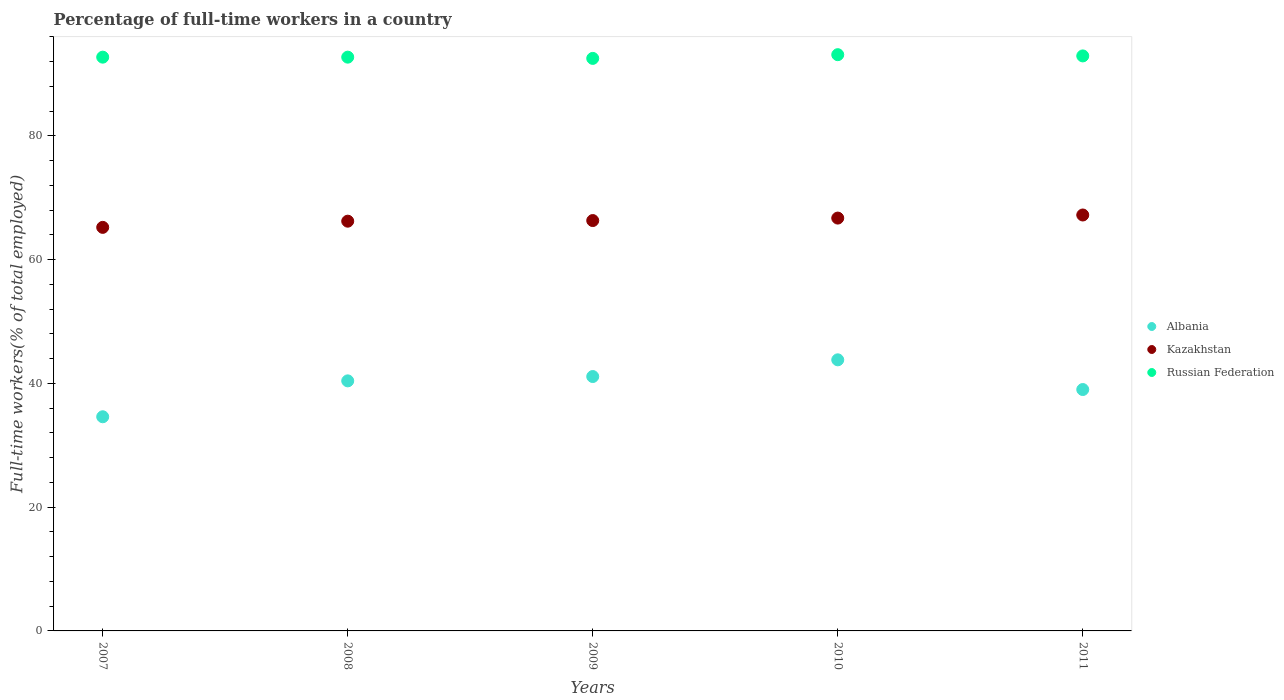How many different coloured dotlines are there?
Your response must be concise. 3. Is the number of dotlines equal to the number of legend labels?
Your answer should be very brief. Yes. What is the percentage of full-time workers in Albania in 2009?
Offer a terse response. 41.1. Across all years, what is the maximum percentage of full-time workers in Albania?
Your answer should be compact. 43.8. Across all years, what is the minimum percentage of full-time workers in Albania?
Provide a short and direct response. 34.6. In which year was the percentage of full-time workers in Russian Federation maximum?
Provide a short and direct response. 2010. What is the total percentage of full-time workers in Russian Federation in the graph?
Your response must be concise. 463.9. What is the difference between the percentage of full-time workers in Russian Federation in 2008 and that in 2009?
Give a very brief answer. 0.2. What is the difference between the percentage of full-time workers in Russian Federation in 2011 and the percentage of full-time workers in Kazakhstan in 2008?
Make the answer very short. 26.7. What is the average percentage of full-time workers in Kazakhstan per year?
Your response must be concise. 66.32. In the year 2011, what is the difference between the percentage of full-time workers in Russian Federation and percentage of full-time workers in Kazakhstan?
Make the answer very short. 25.7. What is the ratio of the percentage of full-time workers in Albania in 2009 to that in 2010?
Keep it short and to the point. 0.94. Is the percentage of full-time workers in Kazakhstan in 2008 less than that in 2011?
Give a very brief answer. Yes. What is the difference between the highest and the lowest percentage of full-time workers in Russian Federation?
Offer a very short reply. 0.6. Does the percentage of full-time workers in Kazakhstan monotonically increase over the years?
Your answer should be compact. Yes. Is the percentage of full-time workers in Kazakhstan strictly less than the percentage of full-time workers in Russian Federation over the years?
Your answer should be compact. Yes. How many dotlines are there?
Make the answer very short. 3. What is the difference between two consecutive major ticks on the Y-axis?
Ensure brevity in your answer.  20. Are the values on the major ticks of Y-axis written in scientific E-notation?
Your answer should be very brief. No. Does the graph contain grids?
Your response must be concise. No. How many legend labels are there?
Give a very brief answer. 3. How are the legend labels stacked?
Your answer should be compact. Vertical. What is the title of the graph?
Ensure brevity in your answer.  Percentage of full-time workers in a country. What is the label or title of the X-axis?
Offer a terse response. Years. What is the label or title of the Y-axis?
Ensure brevity in your answer.  Full-time workers(% of total employed). What is the Full-time workers(% of total employed) of Albania in 2007?
Give a very brief answer. 34.6. What is the Full-time workers(% of total employed) of Kazakhstan in 2007?
Provide a short and direct response. 65.2. What is the Full-time workers(% of total employed) in Russian Federation in 2007?
Make the answer very short. 92.7. What is the Full-time workers(% of total employed) of Albania in 2008?
Make the answer very short. 40.4. What is the Full-time workers(% of total employed) of Kazakhstan in 2008?
Make the answer very short. 66.2. What is the Full-time workers(% of total employed) in Russian Federation in 2008?
Your answer should be very brief. 92.7. What is the Full-time workers(% of total employed) in Albania in 2009?
Give a very brief answer. 41.1. What is the Full-time workers(% of total employed) of Kazakhstan in 2009?
Keep it short and to the point. 66.3. What is the Full-time workers(% of total employed) of Russian Federation in 2009?
Keep it short and to the point. 92.5. What is the Full-time workers(% of total employed) of Albania in 2010?
Ensure brevity in your answer.  43.8. What is the Full-time workers(% of total employed) of Kazakhstan in 2010?
Offer a terse response. 66.7. What is the Full-time workers(% of total employed) of Russian Federation in 2010?
Give a very brief answer. 93.1. What is the Full-time workers(% of total employed) of Albania in 2011?
Your answer should be compact. 39. What is the Full-time workers(% of total employed) in Kazakhstan in 2011?
Make the answer very short. 67.2. What is the Full-time workers(% of total employed) in Russian Federation in 2011?
Provide a succinct answer. 92.9. Across all years, what is the maximum Full-time workers(% of total employed) in Albania?
Give a very brief answer. 43.8. Across all years, what is the maximum Full-time workers(% of total employed) in Kazakhstan?
Provide a succinct answer. 67.2. Across all years, what is the maximum Full-time workers(% of total employed) of Russian Federation?
Your answer should be compact. 93.1. Across all years, what is the minimum Full-time workers(% of total employed) in Albania?
Your answer should be very brief. 34.6. Across all years, what is the minimum Full-time workers(% of total employed) of Kazakhstan?
Keep it short and to the point. 65.2. Across all years, what is the minimum Full-time workers(% of total employed) of Russian Federation?
Make the answer very short. 92.5. What is the total Full-time workers(% of total employed) in Albania in the graph?
Provide a succinct answer. 198.9. What is the total Full-time workers(% of total employed) of Kazakhstan in the graph?
Your response must be concise. 331.6. What is the total Full-time workers(% of total employed) of Russian Federation in the graph?
Provide a short and direct response. 463.9. What is the difference between the Full-time workers(% of total employed) in Albania in 2007 and that in 2008?
Your response must be concise. -5.8. What is the difference between the Full-time workers(% of total employed) of Kazakhstan in 2007 and that in 2008?
Offer a very short reply. -1. What is the difference between the Full-time workers(% of total employed) of Russian Federation in 2007 and that in 2009?
Keep it short and to the point. 0.2. What is the difference between the Full-time workers(% of total employed) of Kazakhstan in 2007 and that in 2010?
Provide a succinct answer. -1.5. What is the difference between the Full-time workers(% of total employed) in Russian Federation in 2007 and that in 2010?
Provide a short and direct response. -0.4. What is the difference between the Full-time workers(% of total employed) of Kazakhstan in 2007 and that in 2011?
Keep it short and to the point. -2. What is the difference between the Full-time workers(% of total employed) in Russian Federation in 2007 and that in 2011?
Your response must be concise. -0.2. What is the difference between the Full-time workers(% of total employed) in Albania in 2008 and that in 2009?
Your answer should be very brief. -0.7. What is the difference between the Full-time workers(% of total employed) of Kazakhstan in 2008 and that in 2009?
Provide a short and direct response. -0.1. What is the difference between the Full-time workers(% of total employed) in Russian Federation in 2008 and that in 2009?
Make the answer very short. 0.2. What is the difference between the Full-time workers(% of total employed) in Russian Federation in 2008 and that in 2010?
Your answer should be very brief. -0.4. What is the difference between the Full-time workers(% of total employed) of Kazakhstan in 2008 and that in 2011?
Keep it short and to the point. -1. What is the difference between the Full-time workers(% of total employed) in Albania in 2009 and that in 2010?
Provide a succinct answer. -2.7. What is the difference between the Full-time workers(% of total employed) in Kazakhstan in 2009 and that in 2010?
Keep it short and to the point. -0.4. What is the difference between the Full-time workers(% of total employed) of Albania in 2009 and that in 2011?
Offer a terse response. 2.1. What is the difference between the Full-time workers(% of total employed) of Albania in 2010 and that in 2011?
Your answer should be very brief. 4.8. What is the difference between the Full-time workers(% of total employed) of Russian Federation in 2010 and that in 2011?
Offer a very short reply. 0.2. What is the difference between the Full-time workers(% of total employed) of Albania in 2007 and the Full-time workers(% of total employed) of Kazakhstan in 2008?
Keep it short and to the point. -31.6. What is the difference between the Full-time workers(% of total employed) in Albania in 2007 and the Full-time workers(% of total employed) in Russian Federation in 2008?
Offer a very short reply. -58.1. What is the difference between the Full-time workers(% of total employed) in Kazakhstan in 2007 and the Full-time workers(% of total employed) in Russian Federation in 2008?
Keep it short and to the point. -27.5. What is the difference between the Full-time workers(% of total employed) in Albania in 2007 and the Full-time workers(% of total employed) in Kazakhstan in 2009?
Keep it short and to the point. -31.7. What is the difference between the Full-time workers(% of total employed) in Albania in 2007 and the Full-time workers(% of total employed) in Russian Federation in 2009?
Make the answer very short. -57.9. What is the difference between the Full-time workers(% of total employed) in Kazakhstan in 2007 and the Full-time workers(% of total employed) in Russian Federation in 2009?
Offer a terse response. -27.3. What is the difference between the Full-time workers(% of total employed) in Albania in 2007 and the Full-time workers(% of total employed) in Kazakhstan in 2010?
Make the answer very short. -32.1. What is the difference between the Full-time workers(% of total employed) of Albania in 2007 and the Full-time workers(% of total employed) of Russian Federation in 2010?
Your response must be concise. -58.5. What is the difference between the Full-time workers(% of total employed) of Kazakhstan in 2007 and the Full-time workers(% of total employed) of Russian Federation in 2010?
Give a very brief answer. -27.9. What is the difference between the Full-time workers(% of total employed) in Albania in 2007 and the Full-time workers(% of total employed) in Kazakhstan in 2011?
Make the answer very short. -32.6. What is the difference between the Full-time workers(% of total employed) of Albania in 2007 and the Full-time workers(% of total employed) of Russian Federation in 2011?
Ensure brevity in your answer.  -58.3. What is the difference between the Full-time workers(% of total employed) in Kazakhstan in 2007 and the Full-time workers(% of total employed) in Russian Federation in 2011?
Keep it short and to the point. -27.7. What is the difference between the Full-time workers(% of total employed) in Albania in 2008 and the Full-time workers(% of total employed) in Kazakhstan in 2009?
Give a very brief answer. -25.9. What is the difference between the Full-time workers(% of total employed) of Albania in 2008 and the Full-time workers(% of total employed) of Russian Federation in 2009?
Your response must be concise. -52.1. What is the difference between the Full-time workers(% of total employed) of Kazakhstan in 2008 and the Full-time workers(% of total employed) of Russian Federation in 2009?
Give a very brief answer. -26.3. What is the difference between the Full-time workers(% of total employed) in Albania in 2008 and the Full-time workers(% of total employed) in Kazakhstan in 2010?
Provide a succinct answer. -26.3. What is the difference between the Full-time workers(% of total employed) in Albania in 2008 and the Full-time workers(% of total employed) in Russian Federation in 2010?
Offer a very short reply. -52.7. What is the difference between the Full-time workers(% of total employed) in Kazakhstan in 2008 and the Full-time workers(% of total employed) in Russian Federation in 2010?
Provide a short and direct response. -26.9. What is the difference between the Full-time workers(% of total employed) in Albania in 2008 and the Full-time workers(% of total employed) in Kazakhstan in 2011?
Your answer should be very brief. -26.8. What is the difference between the Full-time workers(% of total employed) in Albania in 2008 and the Full-time workers(% of total employed) in Russian Federation in 2011?
Your answer should be compact. -52.5. What is the difference between the Full-time workers(% of total employed) of Kazakhstan in 2008 and the Full-time workers(% of total employed) of Russian Federation in 2011?
Offer a terse response. -26.7. What is the difference between the Full-time workers(% of total employed) in Albania in 2009 and the Full-time workers(% of total employed) in Kazakhstan in 2010?
Provide a succinct answer. -25.6. What is the difference between the Full-time workers(% of total employed) in Albania in 2009 and the Full-time workers(% of total employed) in Russian Federation in 2010?
Offer a terse response. -52. What is the difference between the Full-time workers(% of total employed) of Kazakhstan in 2009 and the Full-time workers(% of total employed) of Russian Federation in 2010?
Provide a succinct answer. -26.8. What is the difference between the Full-time workers(% of total employed) of Albania in 2009 and the Full-time workers(% of total employed) of Kazakhstan in 2011?
Offer a very short reply. -26.1. What is the difference between the Full-time workers(% of total employed) of Albania in 2009 and the Full-time workers(% of total employed) of Russian Federation in 2011?
Make the answer very short. -51.8. What is the difference between the Full-time workers(% of total employed) of Kazakhstan in 2009 and the Full-time workers(% of total employed) of Russian Federation in 2011?
Give a very brief answer. -26.6. What is the difference between the Full-time workers(% of total employed) in Albania in 2010 and the Full-time workers(% of total employed) in Kazakhstan in 2011?
Ensure brevity in your answer.  -23.4. What is the difference between the Full-time workers(% of total employed) in Albania in 2010 and the Full-time workers(% of total employed) in Russian Federation in 2011?
Keep it short and to the point. -49.1. What is the difference between the Full-time workers(% of total employed) of Kazakhstan in 2010 and the Full-time workers(% of total employed) of Russian Federation in 2011?
Ensure brevity in your answer.  -26.2. What is the average Full-time workers(% of total employed) in Albania per year?
Ensure brevity in your answer.  39.78. What is the average Full-time workers(% of total employed) of Kazakhstan per year?
Your answer should be compact. 66.32. What is the average Full-time workers(% of total employed) in Russian Federation per year?
Offer a terse response. 92.78. In the year 2007, what is the difference between the Full-time workers(% of total employed) in Albania and Full-time workers(% of total employed) in Kazakhstan?
Ensure brevity in your answer.  -30.6. In the year 2007, what is the difference between the Full-time workers(% of total employed) in Albania and Full-time workers(% of total employed) in Russian Federation?
Offer a very short reply. -58.1. In the year 2007, what is the difference between the Full-time workers(% of total employed) in Kazakhstan and Full-time workers(% of total employed) in Russian Federation?
Provide a succinct answer. -27.5. In the year 2008, what is the difference between the Full-time workers(% of total employed) of Albania and Full-time workers(% of total employed) of Kazakhstan?
Keep it short and to the point. -25.8. In the year 2008, what is the difference between the Full-time workers(% of total employed) of Albania and Full-time workers(% of total employed) of Russian Federation?
Provide a short and direct response. -52.3. In the year 2008, what is the difference between the Full-time workers(% of total employed) in Kazakhstan and Full-time workers(% of total employed) in Russian Federation?
Offer a very short reply. -26.5. In the year 2009, what is the difference between the Full-time workers(% of total employed) in Albania and Full-time workers(% of total employed) in Kazakhstan?
Keep it short and to the point. -25.2. In the year 2009, what is the difference between the Full-time workers(% of total employed) of Albania and Full-time workers(% of total employed) of Russian Federation?
Your answer should be compact. -51.4. In the year 2009, what is the difference between the Full-time workers(% of total employed) of Kazakhstan and Full-time workers(% of total employed) of Russian Federation?
Provide a short and direct response. -26.2. In the year 2010, what is the difference between the Full-time workers(% of total employed) in Albania and Full-time workers(% of total employed) in Kazakhstan?
Provide a short and direct response. -22.9. In the year 2010, what is the difference between the Full-time workers(% of total employed) in Albania and Full-time workers(% of total employed) in Russian Federation?
Offer a terse response. -49.3. In the year 2010, what is the difference between the Full-time workers(% of total employed) in Kazakhstan and Full-time workers(% of total employed) in Russian Federation?
Your answer should be very brief. -26.4. In the year 2011, what is the difference between the Full-time workers(% of total employed) of Albania and Full-time workers(% of total employed) of Kazakhstan?
Provide a short and direct response. -28.2. In the year 2011, what is the difference between the Full-time workers(% of total employed) in Albania and Full-time workers(% of total employed) in Russian Federation?
Give a very brief answer. -53.9. In the year 2011, what is the difference between the Full-time workers(% of total employed) in Kazakhstan and Full-time workers(% of total employed) in Russian Federation?
Your response must be concise. -25.7. What is the ratio of the Full-time workers(% of total employed) in Albania in 2007 to that in 2008?
Your response must be concise. 0.86. What is the ratio of the Full-time workers(% of total employed) of Kazakhstan in 2007 to that in 2008?
Offer a very short reply. 0.98. What is the ratio of the Full-time workers(% of total employed) in Russian Federation in 2007 to that in 2008?
Offer a very short reply. 1. What is the ratio of the Full-time workers(% of total employed) of Albania in 2007 to that in 2009?
Provide a succinct answer. 0.84. What is the ratio of the Full-time workers(% of total employed) of Kazakhstan in 2007 to that in 2009?
Give a very brief answer. 0.98. What is the ratio of the Full-time workers(% of total employed) in Russian Federation in 2007 to that in 2009?
Offer a very short reply. 1. What is the ratio of the Full-time workers(% of total employed) in Albania in 2007 to that in 2010?
Keep it short and to the point. 0.79. What is the ratio of the Full-time workers(% of total employed) in Kazakhstan in 2007 to that in 2010?
Make the answer very short. 0.98. What is the ratio of the Full-time workers(% of total employed) in Albania in 2007 to that in 2011?
Your response must be concise. 0.89. What is the ratio of the Full-time workers(% of total employed) of Kazakhstan in 2007 to that in 2011?
Your answer should be compact. 0.97. What is the ratio of the Full-time workers(% of total employed) in Albania in 2008 to that in 2009?
Provide a succinct answer. 0.98. What is the ratio of the Full-time workers(% of total employed) of Russian Federation in 2008 to that in 2009?
Give a very brief answer. 1. What is the ratio of the Full-time workers(% of total employed) in Albania in 2008 to that in 2010?
Provide a succinct answer. 0.92. What is the ratio of the Full-time workers(% of total employed) in Albania in 2008 to that in 2011?
Offer a very short reply. 1.04. What is the ratio of the Full-time workers(% of total employed) of Kazakhstan in 2008 to that in 2011?
Offer a terse response. 0.99. What is the ratio of the Full-time workers(% of total employed) of Russian Federation in 2008 to that in 2011?
Your answer should be very brief. 1. What is the ratio of the Full-time workers(% of total employed) in Albania in 2009 to that in 2010?
Give a very brief answer. 0.94. What is the ratio of the Full-time workers(% of total employed) of Russian Federation in 2009 to that in 2010?
Your answer should be very brief. 0.99. What is the ratio of the Full-time workers(% of total employed) in Albania in 2009 to that in 2011?
Keep it short and to the point. 1.05. What is the ratio of the Full-time workers(% of total employed) of Kazakhstan in 2009 to that in 2011?
Provide a succinct answer. 0.99. What is the ratio of the Full-time workers(% of total employed) in Russian Federation in 2009 to that in 2011?
Your answer should be compact. 1. What is the ratio of the Full-time workers(% of total employed) of Albania in 2010 to that in 2011?
Your answer should be compact. 1.12. What is the ratio of the Full-time workers(% of total employed) in Kazakhstan in 2010 to that in 2011?
Offer a terse response. 0.99. What is the ratio of the Full-time workers(% of total employed) in Russian Federation in 2010 to that in 2011?
Make the answer very short. 1. What is the difference between the highest and the second highest Full-time workers(% of total employed) of Russian Federation?
Keep it short and to the point. 0.2. What is the difference between the highest and the lowest Full-time workers(% of total employed) in Albania?
Make the answer very short. 9.2. What is the difference between the highest and the lowest Full-time workers(% of total employed) of Russian Federation?
Offer a very short reply. 0.6. 